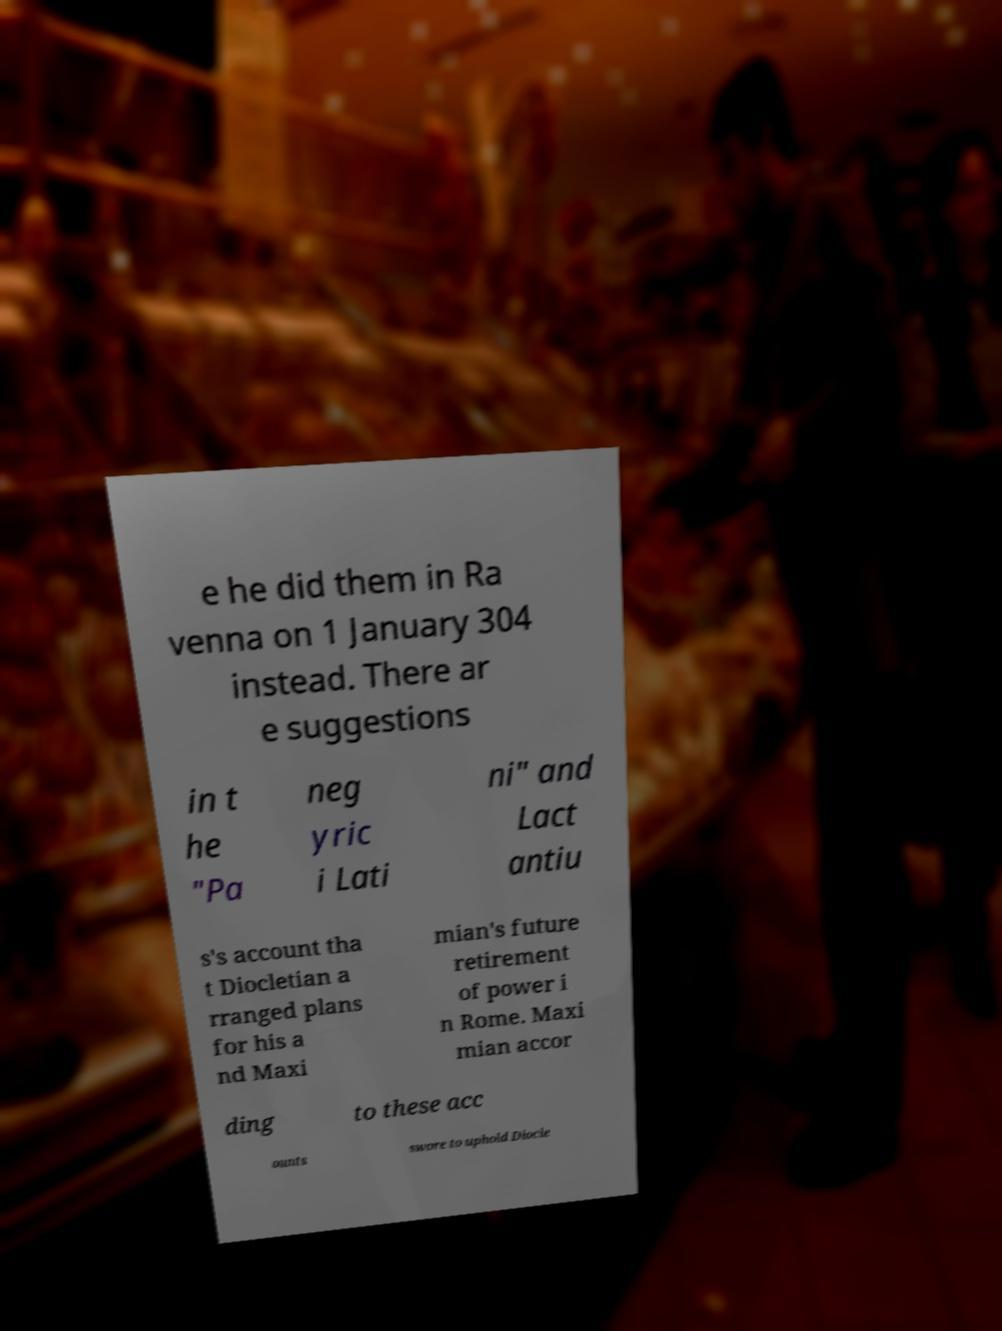Could you assist in decoding the text presented in this image and type it out clearly? e he did them in Ra venna on 1 January 304 instead. There ar e suggestions in t he "Pa neg yric i Lati ni" and Lact antiu s's account tha t Diocletian a rranged plans for his a nd Maxi mian's future retirement of power i n Rome. Maxi mian accor ding to these acc ounts swore to uphold Diocle 